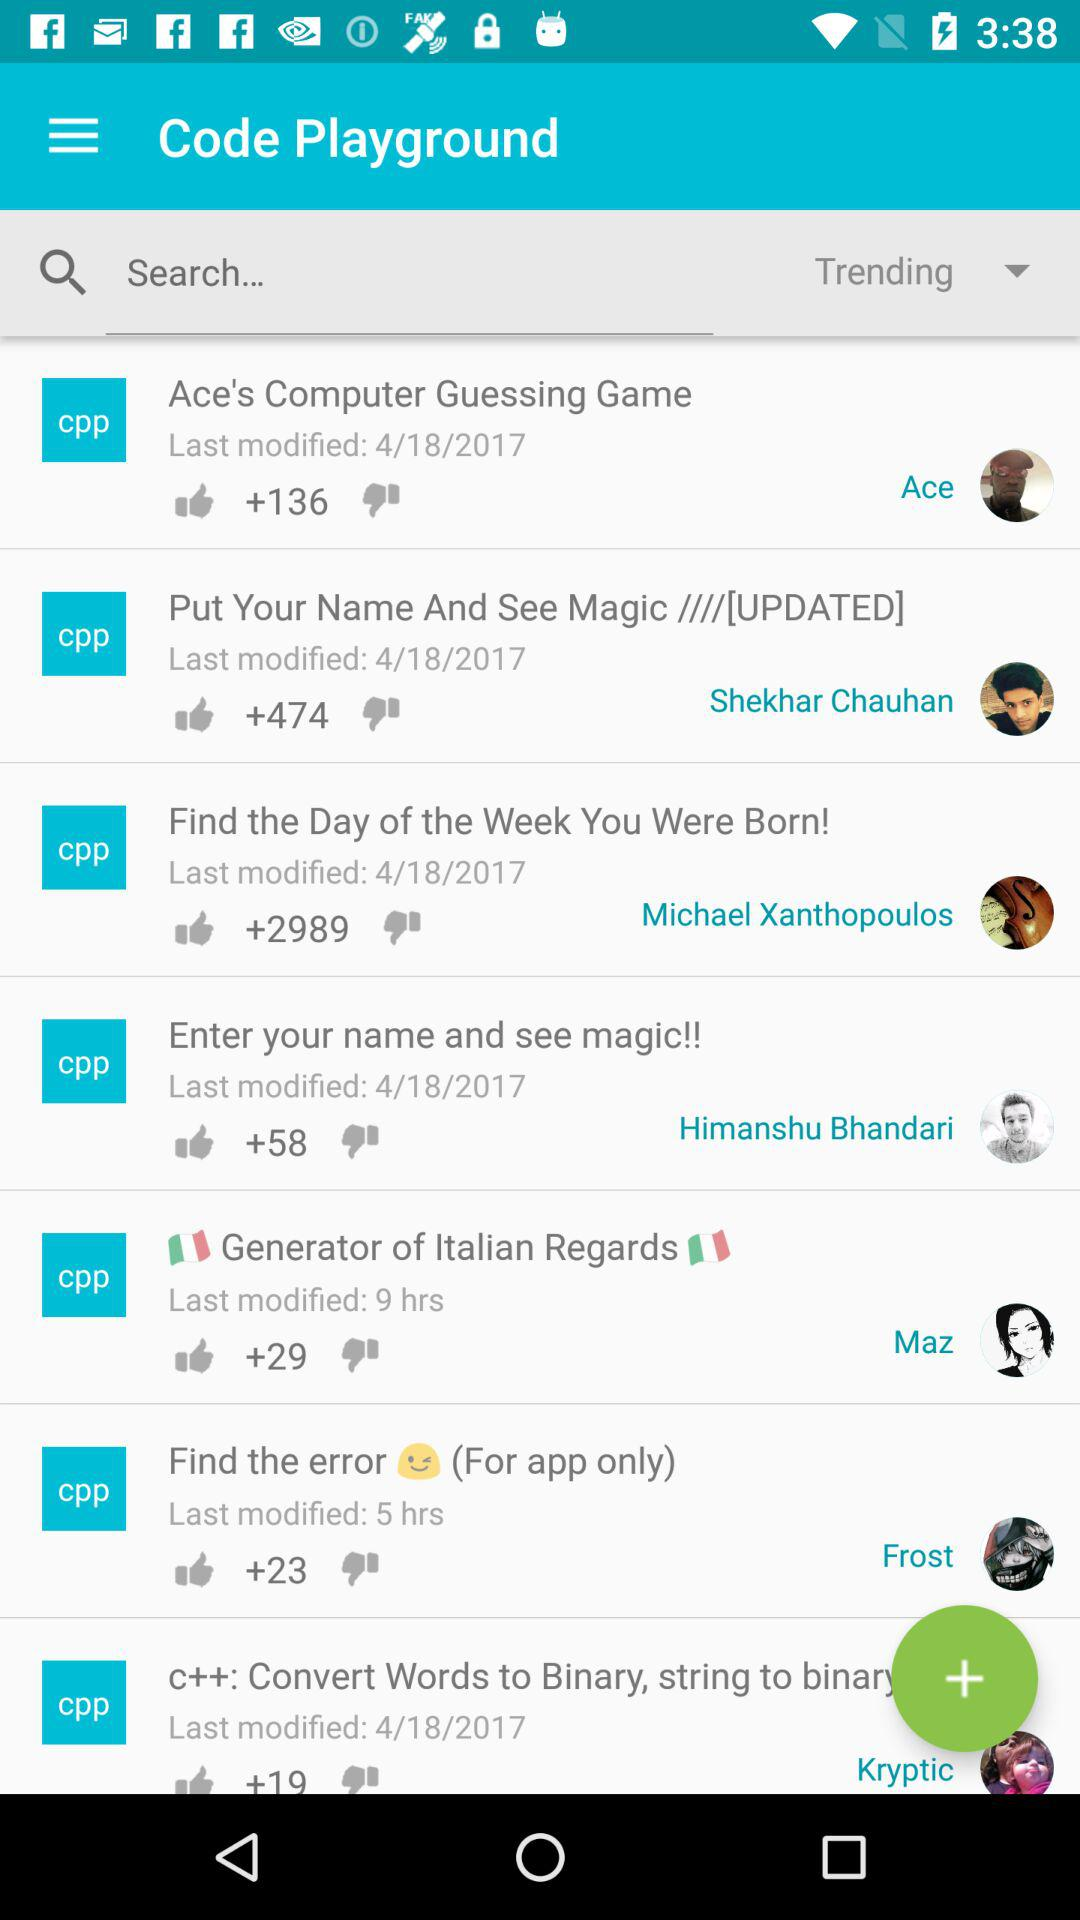How many thumbs up does the item with the most thumbs up have? 2989 